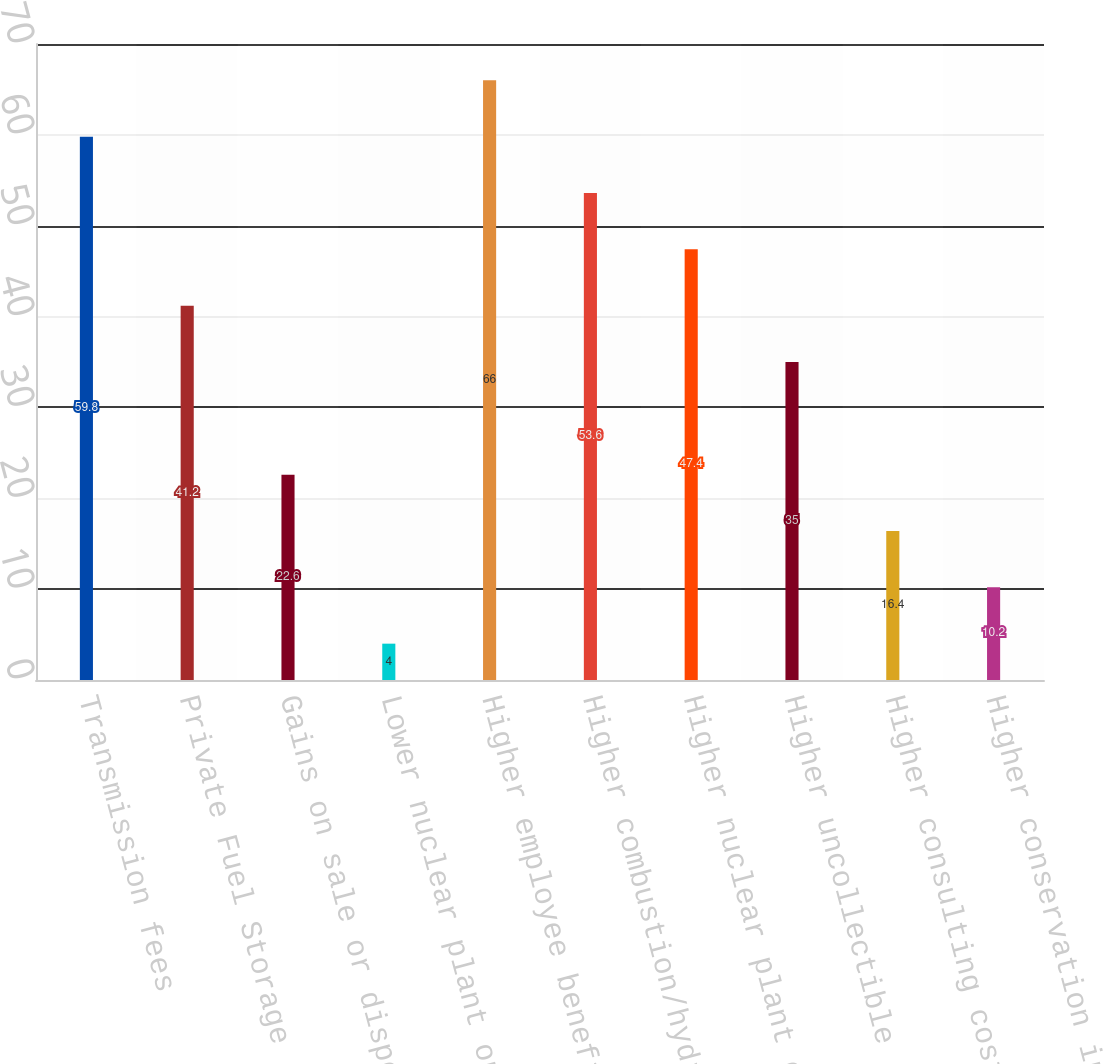Convert chart to OTSL. <chart><loc_0><loc_0><loc_500><loc_500><bar_chart><fcel>Transmission fees<fcel>Private Fuel Storage<fcel>Gains on sale or disposal of<fcel>Lower nuclear plant outage<fcel>Higher employee benefit costs<fcel>Higher combustion/hydro plant<fcel>Higher nuclear plant operating<fcel>Higher uncollectible<fcel>Higher consulting costs<fcel>Higher conservation incentive<nl><fcel>59.8<fcel>41.2<fcel>22.6<fcel>4<fcel>66<fcel>53.6<fcel>47.4<fcel>35<fcel>16.4<fcel>10.2<nl></chart> 